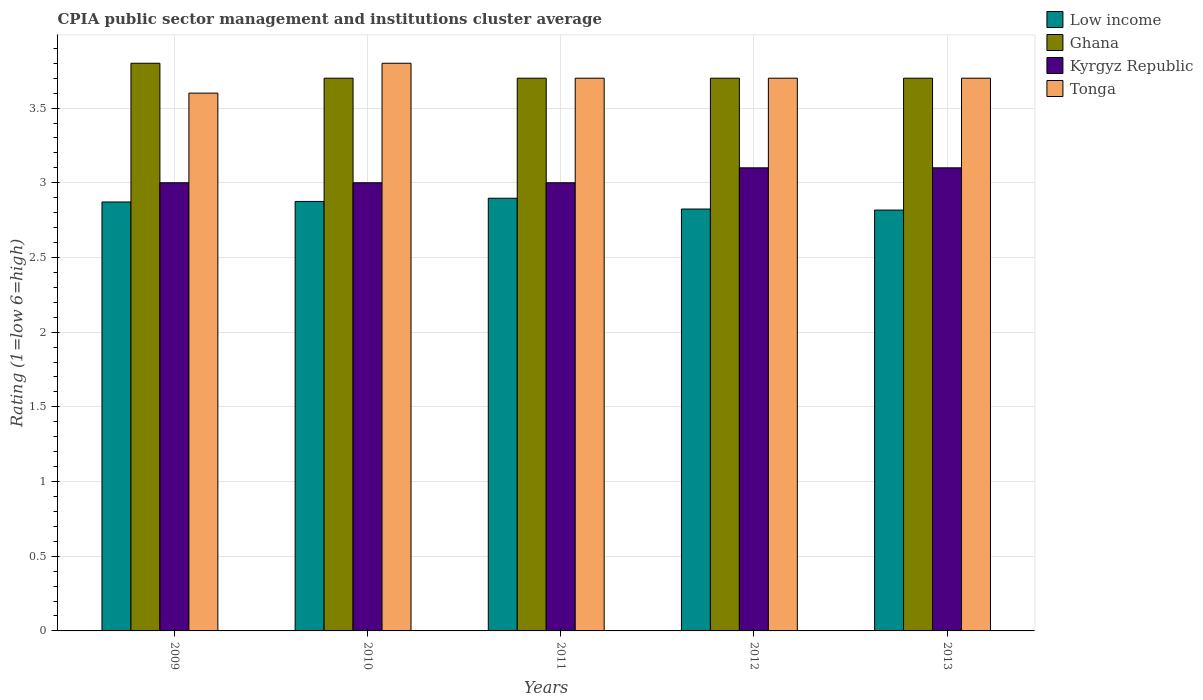How many groups of bars are there?
Keep it short and to the point. 5. Are the number of bars on each tick of the X-axis equal?
Offer a very short reply. Yes. In how many cases, is the number of bars for a given year not equal to the number of legend labels?
Offer a terse response. 0. What is the CPIA rating in Kyrgyz Republic in 2011?
Your answer should be compact. 3. Across all years, what is the maximum CPIA rating in Low income?
Your answer should be very brief. 2.9. Across all years, what is the minimum CPIA rating in Low income?
Offer a terse response. 2.82. In which year was the CPIA rating in Low income maximum?
Give a very brief answer. 2011. In which year was the CPIA rating in Tonga minimum?
Ensure brevity in your answer.  2009. What is the total CPIA rating in Ghana in the graph?
Offer a terse response. 18.6. What is the difference between the CPIA rating in Tonga in 2011 and that in 2012?
Your answer should be compact. 0. What is the difference between the CPIA rating in Tonga in 2011 and the CPIA rating in Kyrgyz Republic in 2013?
Your answer should be compact. 0.6. What is the average CPIA rating in Kyrgyz Republic per year?
Keep it short and to the point. 3.04. In the year 2010, what is the difference between the CPIA rating in Ghana and CPIA rating in Low income?
Offer a terse response. 0.83. In how many years, is the CPIA rating in Kyrgyz Republic greater than 2.6?
Offer a terse response. 5. What is the ratio of the CPIA rating in Tonga in 2010 to that in 2012?
Make the answer very short. 1.03. Is the difference between the CPIA rating in Ghana in 2009 and 2012 greater than the difference between the CPIA rating in Low income in 2009 and 2012?
Provide a succinct answer. Yes. What is the difference between the highest and the second highest CPIA rating in Ghana?
Provide a short and direct response. 0.1. What is the difference between the highest and the lowest CPIA rating in Tonga?
Your answer should be very brief. 0.2. Is the sum of the CPIA rating in Kyrgyz Republic in 2012 and 2013 greater than the maximum CPIA rating in Low income across all years?
Offer a terse response. Yes. Is it the case that in every year, the sum of the CPIA rating in Low income and CPIA rating in Kyrgyz Republic is greater than the sum of CPIA rating in Ghana and CPIA rating in Tonga?
Your answer should be compact. Yes. What does the 3rd bar from the left in 2011 represents?
Your response must be concise. Kyrgyz Republic. Does the graph contain any zero values?
Your answer should be very brief. No. Where does the legend appear in the graph?
Provide a succinct answer. Top right. What is the title of the graph?
Your answer should be very brief. CPIA public sector management and institutions cluster average. Does "Congo (Democratic)" appear as one of the legend labels in the graph?
Make the answer very short. No. What is the label or title of the Y-axis?
Give a very brief answer. Rating (1=low 6=high). What is the Rating (1=low 6=high) in Low income in 2009?
Your response must be concise. 2.87. What is the Rating (1=low 6=high) of Ghana in 2009?
Offer a terse response. 3.8. What is the Rating (1=low 6=high) of Low income in 2010?
Make the answer very short. 2.88. What is the Rating (1=low 6=high) in Kyrgyz Republic in 2010?
Ensure brevity in your answer.  3. What is the Rating (1=low 6=high) in Tonga in 2010?
Your answer should be compact. 3.8. What is the Rating (1=low 6=high) in Low income in 2011?
Offer a terse response. 2.9. What is the Rating (1=low 6=high) of Kyrgyz Republic in 2011?
Provide a succinct answer. 3. What is the Rating (1=low 6=high) in Tonga in 2011?
Offer a very short reply. 3.7. What is the Rating (1=low 6=high) in Low income in 2012?
Give a very brief answer. 2.82. What is the Rating (1=low 6=high) of Kyrgyz Republic in 2012?
Offer a very short reply. 3.1. What is the Rating (1=low 6=high) in Low income in 2013?
Your response must be concise. 2.82. What is the Rating (1=low 6=high) in Ghana in 2013?
Your response must be concise. 3.7. Across all years, what is the maximum Rating (1=low 6=high) of Low income?
Offer a terse response. 2.9. Across all years, what is the maximum Rating (1=low 6=high) of Ghana?
Give a very brief answer. 3.8. Across all years, what is the maximum Rating (1=low 6=high) of Tonga?
Make the answer very short. 3.8. Across all years, what is the minimum Rating (1=low 6=high) in Low income?
Your response must be concise. 2.82. Across all years, what is the minimum Rating (1=low 6=high) in Ghana?
Your response must be concise. 3.7. What is the total Rating (1=low 6=high) of Low income in the graph?
Make the answer very short. 14.28. What is the total Rating (1=low 6=high) in Kyrgyz Republic in the graph?
Keep it short and to the point. 15.2. What is the difference between the Rating (1=low 6=high) of Low income in 2009 and that in 2010?
Ensure brevity in your answer.  -0. What is the difference between the Rating (1=low 6=high) of Ghana in 2009 and that in 2010?
Give a very brief answer. 0.1. What is the difference between the Rating (1=low 6=high) of Kyrgyz Republic in 2009 and that in 2010?
Keep it short and to the point. 0. What is the difference between the Rating (1=low 6=high) in Low income in 2009 and that in 2011?
Provide a short and direct response. -0.03. What is the difference between the Rating (1=low 6=high) of Low income in 2009 and that in 2012?
Your response must be concise. 0.05. What is the difference between the Rating (1=low 6=high) of Ghana in 2009 and that in 2012?
Offer a terse response. 0.1. What is the difference between the Rating (1=low 6=high) of Low income in 2009 and that in 2013?
Provide a succinct answer. 0.05. What is the difference between the Rating (1=low 6=high) in Ghana in 2009 and that in 2013?
Keep it short and to the point. 0.1. What is the difference between the Rating (1=low 6=high) in Kyrgyz Republic in 2009 and that in 2013?
Provide a short and direct response. -0.1. What is the difference between the Rating (1=low 6=high) of Tonga in 2009 and that in 2013?
Provide a short and direct response. -0.1. What is the difference between the Rating (1=low 6=high) in Low income in 2010 and that in 2011?
Offer a very short reply. -0.02. What is the difference between the Rating (1=low 6=high) of Ghana in 2010 and that in 2011?
Give a very brief answer. 0. What is the difference between the Rating (1=low 6=high) of Kyrgyz Republic in 2010 and that in 2011?
Your response must be concise. 0. What is the difference between the Rating (1=low 6=high) in Low income in 2010 and that in 2012?
Ensure brevity in your answer.  0.05. What is the difference between the Rating (1=low 6=high) in Low income in 2010 and that in 2013?
Your answer should be very brief. 0.06. What is the difference between the Rating (1=low 6=high) of Kyrgyz Republic in 2010 and that in 2013?
Provide a succinct answer. -0.1. What is the difference between the Rating (1=low 6=high) of Low income in 2011 and that in 2012?
Make the answer very short. 0.07. What is the difference between the Rating (1=low 6=high) of Tonga in 2011 and that in 2012?
Provide a succinct answer. 0. What is the difference between the Rating (1=low 6=high) of Low income in 2011 and that in 2013?
Make the answer very short. 0.08. What is the difference between the Rating (1=low 6=high) in Tonga in 2011 and that in 2013?
Give a very brief answer. 0. What is the difference between the Rating (1=low 6=high) of Low income in 2012 and that in 2013?
Offer a very short reply. 0.01. What is the difference between the Rating (1=low 6=high) of Ghana in 2012 and that in 2013?
Your answer should be very brief. 0. What is the difference between the Rating (1=low 6=high) in Kyrgyz Republic in 2012 and that in 2013?
Keep it short and to the point. 0. What is the difference between the Rating (1=low 6=high) in Tonga in 2012 and that in 2013?
Offer a very short reply. 0. What is the difference between the Rating (1=low 6=high) of Low income in 2009 and the Rating (1=low 6=high) of Ghana in 2010?
Provide a succinct answer. -0.83. What is the difference between the Rating (1=low 6=high) of Low income in 2009 and the Rating (1=low 6=high) of Kyrgyz Republic in 2010?
Offer a very short reply. -0.13. What is the difference between the Rating (1=low 6=high) of Low income in 2009 and the Rating (1=low 6=high) of Tonga in 2010?
Ensure brevity in your answer.  -0.93. What is the difference between the Rating (1=low 6=high) in Ghana in 2009 and the Rating (1=low 6=high) in Kyrgyz Republic in 2010?
Your response must be concise. 0.8. What is the difference between the Rating (1=low 6=high) in Low income in 2009 and the Rating (1=low 6=high) in Ghana in 2011?
Make the answer very short. -0.83. What is the difference between the Rating (1=low 6=high) of Low income in 2009 and the Rating (1=low 6=high) of Kyrgyz Republic in 2011?
Give a very brief answer. -0.13. What is the difference between the Rating (1=low 6=high) in Low income in 2009 and the Rating (1=low 6=high) in Tonga in 2011?
Keep it short and to the point. -0.83. What is the difference between the Rating (1=low 6=high) of Ghana in 2009 and the Rating (1=low 6=high) of Kyrgyz Republic in 2011?
Make the answer very short. 0.8. What is the difference between the Rating (1=low 6=high) in Kyrgyz Republic in 2009 and the Rating (1=low 6=high) in Tonga in 2011?
Keep it short and to the point. -0.7. What is the difference between the Rating (1=low 6=high) of Low income in 2009 and the Rating (1=low 6=high) of Ghana in 2012?
Offer a terse response. -0.83. What is the difference between the Rating (1=low 6=high) of Low income in 2009 and the Rating (1=low 6=high) of Kyrgyz Republic in 2012?
Give a very brief answer. -0.23. What is the difference between the Rating (1=low 6=high) in Low income in 2009 and the Rating (1=low 6=high) in Tonga in 2012?
Give a very brief answer. -0.83. What is the difference between the Rating (1=low 6=high) of Ghana in 2009 and the Rating (1=low 6=high) of Kyrgyz Republic in 2012?
Give a very brief answer. 0.7. What is the difference between the Rating (1=low 6=high) of Ghana in 2009 and the Rating (1=low 6=high) of Tonga in 2012?
Provide a succinct answer. 0.1. What is the difference between the Rating (1=low 6=high) of Low income in 2009 and the Rating (1=low 6=high) of Ghana in 2013?
Keep it short and to the point. -0.83. What is the difference between the Rating (1=low 6=high) in Low income in 2009 and the Rating (1=low 6=high) in Kyrgyz Republic in 2013?
Keep it short and to the point. -0.23. What is the difference between the Rating (1=low 6=high) in Low income in 2009 and the Rating (1=low 6=high) in Tonga in 2013?
Make the answer very short. -0.83. What is the difference between the Rating (1=low 6=high) in Ghana in 2009 and the Rating (1=low 6=high) in Tonga in 2013?
Your answer should be compact. 0.1. What is the difference between the Rating (1=low 6=high) in Kyrgyz Republic in 2009 and the Rating (1=low 6=high) in Tonga in 2013?
Give a very brief answer. -0.7. What is the difference between the Rating (1=low 6=high) in Low income in 2010 and the Rating (1=low 6=high) in Ghana in 2011?
Keep it short and to the point. -0.82. What is the difference between the Rating (1=low 6=high) in Low income in 2010 and the Rating (1=low 6=high) in Kyrgyz Republic in 2011?
Give a very brief answer. -0.12. What is the difference between the Rating (1=low 6=high) in Low income in 2010 and the Rating (1=low 6=high) in Tonga in 2011?
Give a very brief answer. -0.82. What is the difference between the Rating (1=low 6=high) in Ghana in 2010 and the Rating (1=low 6=high) in Kyrgyz Republic in 2011?
Provide a succinct answer. 0.7. What is the difference between the Rating (1=low 6=high) of Low income in 2010 and the Rating (1=low 6=high) of Ghana in 2012?
Your response must be concise. -0.82. What is the difference between the Rating (1=low 6=high) in Low income in 2010 and the Rating (1=low 6=high) in Kyrgyz Republic in 2012?
Offer a very short reply. -0.23. What is the difference between the Rating (1=low 6=high) of Low income in 2010 and the Rating (1=low 6=high) of Tonga in 2012?
Give a very brief answer. -0.82. What is the difference between the Rating (1=low 6=high) of Ghana in 2010 and the Rating (1=low 6=high) of Tonga in 2012?
Give a very brief answer. 0. What is the difference between the Rating (1=low 6=high) in Low income in 2010 and the Rating (1=low 6=high) in Ghana in 2013?
Provide a succinct answer. -0.82. What is the difference between the Rating (1=low 6=high) in Low income in 2010 and the Rating (1=low 6=high) in Kyrgyz Republic in 2013?
Ensure brevity in your answer.  -0.23. What is the difference between the Rating (1=low 6=high) in Low income in 2010 and the Rating (1=low 6=high) in Tonga in 2013?
Offer a terse response. -0.82. What is the difference between the Rating (1=low 6=high) of Ghana in 2010 and the Rating (1=low 6=high) of Tonga in 2013?
Offer a very short reply. 0. What is the difference between the Rating (1=low 6=high) in Kyrgyz Republic in 2010 and the Rating (1=low 6=high) in Tonga in 2013?
Offer a terse response. -0.7. What is the difference between the Rating (1=low 6=high) of Low income in 2011 and the Rating (1=low 6=high) of Ghana in 2012?
Provide a succinct answer. -0.8. What is the difference between the Rating (1=low 6=high) of Low income in 2011 and the Rating (1=low 6=high) of Kyrgyz Republic in 2012?
Make the answer very short. -0.2. What is the difference between the Rating (1=low 6=high) of Low income in 2011 and the Rating (1=low 6=high) of Tonga in 2012?
Offer a very short reply. -0.8. What is the difference between the Rating (1=low 6=high) of Ghana in 2011 and the Rating (1=low 6=high) of Tonga in 2012?
Give a very brief answer. 0. What is the difference between the Rating (1=low 6=high) of Kyrgyz Republic in 2011 and the Rating (1=low 6=high) of Tonga in 2012?
Ensure brevity in your answer.  -0.7. What is the difference between the Rating (1=low 6=high) of Low income in 2011 and the Rating (1=low 6=high) of Ghana in 2013?
Keep it short and to the point. -0.8. What is the difference between the Rating (1=low 6=high) of Low income in 2011 and the Rating (1=low 6=high) of Kyrgyz Republic in 2013?
Provide a succinct answer. -0.2. What is the difference between the Rating (1=low 6=high) of Low income in 2011 and the Rating (1=low 6=high) of Tonga in 2013?
Ensure brevity in your answer.  -0.8. What is the difference between the Rating (1=low 6=high) of Ghana in 2011 and the Rating (1=low 6=high) of Kyrgyz Republic in 2013?
Provide a succinct answer. 0.6. What is the difference between the Rating (1=low 6=high) of Ghana in 2011 and the Rating (1=low 6=high) of Tonga in 2013?
Keep it short and to the point. 0. What is the difference between the Rating (1=low 6=high) in Kyrgyz Republic in 2011 and the Rating (1=low 6=high) in Tonga in 2013?
Your answer should be very brief. -0.7. What is the difference between the Rating (1=low 6=high) of Low income in 2012 and the Rating (1=low 6=high) of Ghana in 2013?
Offer a very short reply. -0.88. What is the difference between the Rating (1=low 6=high) of Low income in 2012 and the Rating (1=low 6=high) of Kyrgyz Republic in 2013?
Your response must be concise. -0.28. What is the difference between the Rating (1=low 6=high) of Low income in 2012 and the Rating (1=low 6=high) of Tonga in 2013?
Give a very brief answer. -0.88. What is the difference between the Rating (1=low 6=high) of Ghana in 2012 and the Rating (1=low 6=high) of Kyrgyz Republic in 2013?
Offer a very short reply. 0.6. What is the difference between the Rating (1=low 6=high) of Ghana in 2012 and the Rating (1=low 6=high) of Tonga in 2013?
Ensure brevity in your answer.  0. What is the average Rating (1=low 6=high) of Low income per year?
Give a very brief answer. 2.86. What is the average Rating (1=low 6=high) of Ghana per year?
Your answer should be compact. 3.72. What is the average Rating (1=low 6=high) of Kyrgyz Republic per year?
Make the answer very short. 3.04. What is the average Rating (1=low 6=high) in Tonga per year?
Your response must be concise. 3.7. In the year 2009, what is the difference between the Rating (1=low 6=high) in Low income and Rating (1=low 6=high) in Ghana?
Make the answer very short. -0.93. In the year 2009, what is the difference between the Rating (1=low 6=high) in Low income and Rating (1=low 6=high) in Kyrgyz Republic?
Offer a very short reply. -0.13. In the year 2009, what is the difference between the Rating (1=low 6=high) of Low income and Rating (1=low 6=high) of Tonga?
Give a very brief answer. -0.73. In the year 2010, what is the difference between the Rating (1=low 6=high) in Low income and Rating (1=low 6=high) in Ghana?
Provide a short and direct response. -0.82. In the year 2010, what is the difference between the Rating (1=low 6=high) of Low income and Rating (1=low 6=high) of Kyrgyz Republic?
Provide a short and direct response. -0.12. In the year 2010, what is the difference between the Rating (1=low 6=high) in Low income and Rating (1=low 6=high) in Tonga?
Ensure brevity in your answer.  -0.93. In the year 2010, what is the difference between the Rating (1=low 6=high) in Ghana and Rating (1=low 6=high) in Kyrgyz Republic?
Ensure brevity in your answer.  0.7. In the year 2010, what is the difference between the Rating (1=low 6=high) in Ghana and Rating (1=low 6=high) in Tonga?
Make the answer very short. -0.1. In the year 2010, what is the difference between the Rating (1=low 6=high) in Kyrgyz Republic and Rating (1=low 6=high) in Tonga?
Your response must be concise. -0.8. In the year 2011, what is the difference between the Rating (1=low 6=high) in Low income and Rating (1=low 6=high) in Ghana?
Give a very brief answer. -0.8. In the year 2011, what is the difference between the Rating (1=low 6=high) in Low income and Rating (1=low 6=high) in Kyrgyz Republic?
Make the answer very short. -0.1. In the year 2011, what is the difference between the Rating (1=low 6=high) in Low income and Rating (1=low 6=high) in Tonga?
Offer a terse response. -0.8. In the year 2011, what is the difference between the Rating (1=low 6=high) of Ghana and Rating (1=low 6=high) of Kyrgyz Republic?
Offer a terse response. 0.7. In the year 2011, what is the difference between the Rating (1=low 6=high) in Kyrgyz Republic and Rating (1=low 6=high) in Tonga?
Make the answer very short. -0.7. In the year 2012, what is the difference between the Rating (1=low 6=high) of Low income and Rating (1=low 6=high) of Ghana?
Give a very brief answer. -0.88. In the year 2012, what is the difference between the Rating (1=low 6=high) of Low income and Rating (1=low 6=high) of Kyrgyz Republic?
Your answer should be very brief. -0.28. In the year 2012, what is the difference between the Rating (1=low 6=high) of Low income and Rating (1=low 6=high) of Tonga?
Keep it short and to the point. -0.88. In the year 2012, what is the difference between the Rating (1=low 6=high) in Ghana and Rating (1=low 6=high) in Kyrgyz Republic?
Your answer should be compact. 0.6. In the year 2013, what is the difference between the Rating (1=low 6=high) in Low income and Rating (1=low 6=high) in Ghana?
Keep it short and to the point. -0.88. In the year 2013, what is the difference between the Rating (1=low 6=high) of Low income and Rating (1=low 6=high) of Kyrgyz Republic?
Give a very brief answer. -0.28. In the year 2013, what is the difference between the Rating (1=low 6=high) of Low income and Rating (1=low 6=high) of Tonga?
Provide a short and direct response. -0.88. In the year 2013, what is the difference between the Rating (1=low 6=high) of Ghana and Rating (1=low 6=high) of Kyrgyz Republic?
Provide a short and direct response. 0.6. In the year 2013, what is the difference between the Rating (1=low 6=high) of Kyrgyz Republic and Rating (1=low 6=high) of Tonga?
Provide a succinct answer. -0.6. What is the ratio of the Rating (1=low 6=high) of Kyrgyz Republic in 2009 to that in 2010?
Make the answer very short. 1. What is the ratio of the Rating (1=low 6=high) in Low income in 2009 to that in 2011?
Ensure brevity in your answer.  0.99. What is the ratio of the Rating (1=low 6=high) of Ghana in 2009 to that in 2011?
Offer a terse response. 1.03. What is the ratio of the Rating (1=low 6=high) in Low income in 2009 to that in 2012?
Provide a succinct answer. 1.02. What is the ratio of the Rating (1=low 6=high) of Ghana in 2009 to that in 2012?
Give a very brief answer. 1.03. What is the ratio of the Rating (1=low 6=high) in Kyrgyz Republic in 2009 to that in 2012?
Your answer should be compact. 0.97. What is the ratio of the Rating (1=low 6=high) of Low income in 2009 to that in 2013?
Provide a short and direct response. 1.02. What is the ratio of the Rating (1=low 6=high) in Kyrgyz Republic in 2009 to that in 2013?
Ensure brevity in your answer.  0.97. What is the ratio of the Rating (1=low 6=high) in Tonga in 2009 to that in 2013?
Provide a short and direct response. 0.97. What is the ratio of the Rating (1=low 6=high) of Kyrgyz Republic in 2010 to that in 2011?
Offer a terse response. 1. What is the ratio of the Rating (1=low 6=high) of Tonga in 2010 to that in 2011?
Offer a very short reply. 1.03. What is the ratio of the Rating (1=low 6=high) in Kyrgyz Republic in 2010 to that in 2012?
Keep it short and to the point. 0.97. What is the ratio of the Rating (1=low 6=high) in Low income in 2010 to that in 2013?
Offer a very short reply. 1.02. What is the ratio of the Rating (1=low 6=high) of Kyrgyz Republic in 2010 to that in 2013?
Keep it short and to the point. 0.97. What is the ratio of the Rating (1=low 6=high) in Low income in 2011 to that in 2012?
Offer a very short reply. 1.03. What is the ratio of the Rating (1=low 6=high) of Ghana in 2011 to that in 2012?
Your response must be concise. 1. What is the ratio of the Rating (1=low 6=high) of Tonga in 2011 to that in 2012?
Offer a very short reply. 1. What is the ratio of the Rating (1=low 6=high) in Low income in 2011 to that in 2013?
Your answer should be very brief. 1.03. What is the ratio of the Rating (1=low 6=high) in Tonga in 2011 to that in 2013?
Provide a short and direct response. 1. What is the ratio of the Rating (1=low 6=high) in Low income in 2012 to that in 2013?
Your response must be concise. 1. What is the ratio of the Rating (1=low 6=high) of Ghana in 2012 to that in 2013?
Your answer should be very brief. 1. What is the difference between the highest and the second highest Rating (1=low 6=high) of Low income?
Your response must be concise. 0.02. What is the difference between the highest and the second highest Rating (1=low 6=high) of Ghana?
Provide a succinct answer. 0.1. What is the difference between the highest and the second highest Rating (1=low 6=high) in Kyrgyz Republic?
Give a very brief answer. 0. What is the difference between the highest and the lowest Rating (1=low 6=high) of Low income?
Give a very brief answer. 0.08. What is the difference between the highest and the lowest Rating (1=low 6=high) in Ghana?
Offer a very short reply. 0.1. What is the difference between the highest and the lowest Rating (1=low 6=high) of Kyrgyz Republic?
Keep it short and to the point. 0.1. What is the difference between the highest and the lowest Rating (1=low 6=high) of Tonga?
Your response must be concise. 0.2. 